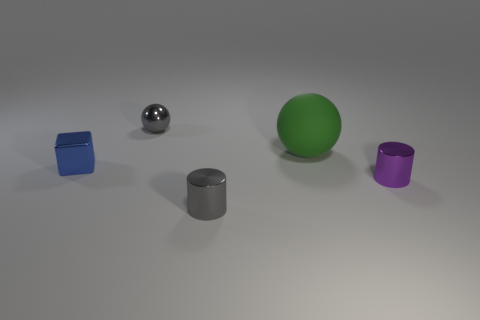What is the color of the large rubber ball? green 